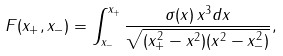Convert formula to latex. <formula><loc_0><loc_0><loc_500><loc_500>F ( x _ { + } , x _ { - } ) = \int _ { x _ { - } } ^ { x _ { + } } \frac { \sigma ( x ) \, x ^ { 3 } d x } { \sqrt { ( x _ { + } ^ { 2 } - x ^ { 2 } ) ( x ^ { 2 } - x _ { - } ^ { 2 } ) } } ,</formula> 